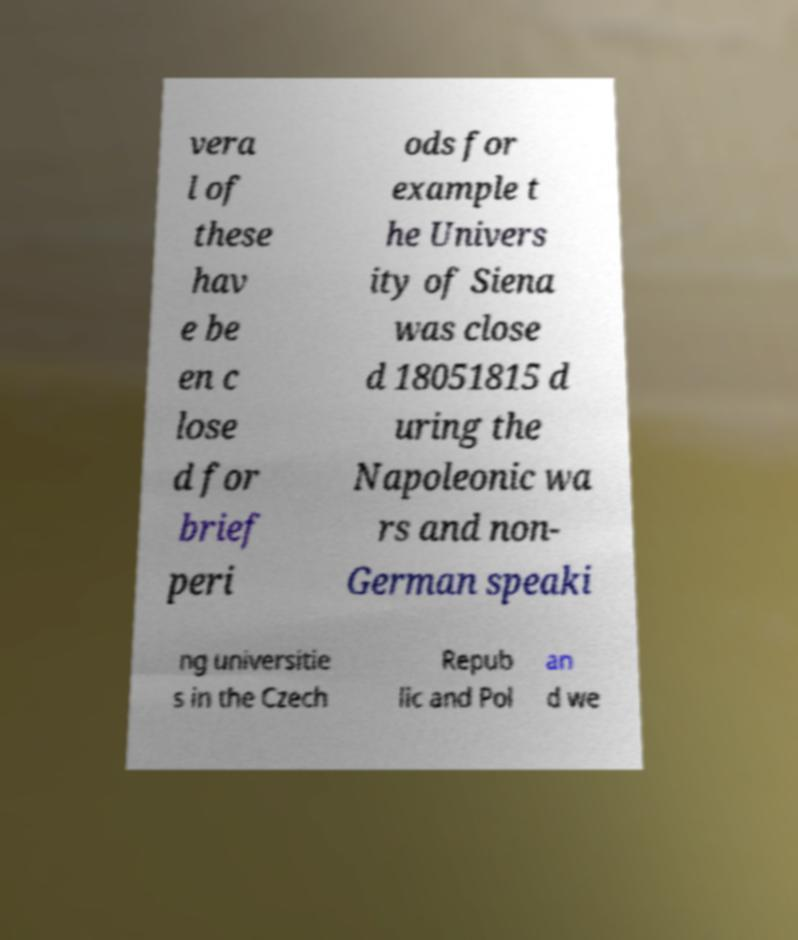Could you extract and type out the text from this image? vera l of these hav e be en c lose d for brief peri ods for example t he Univers ity of Siena was close d 18051815 d uring the Napoleonic wa rs and non- German speaki ng universitie s in the Czech Repub lic and Pol an d we 